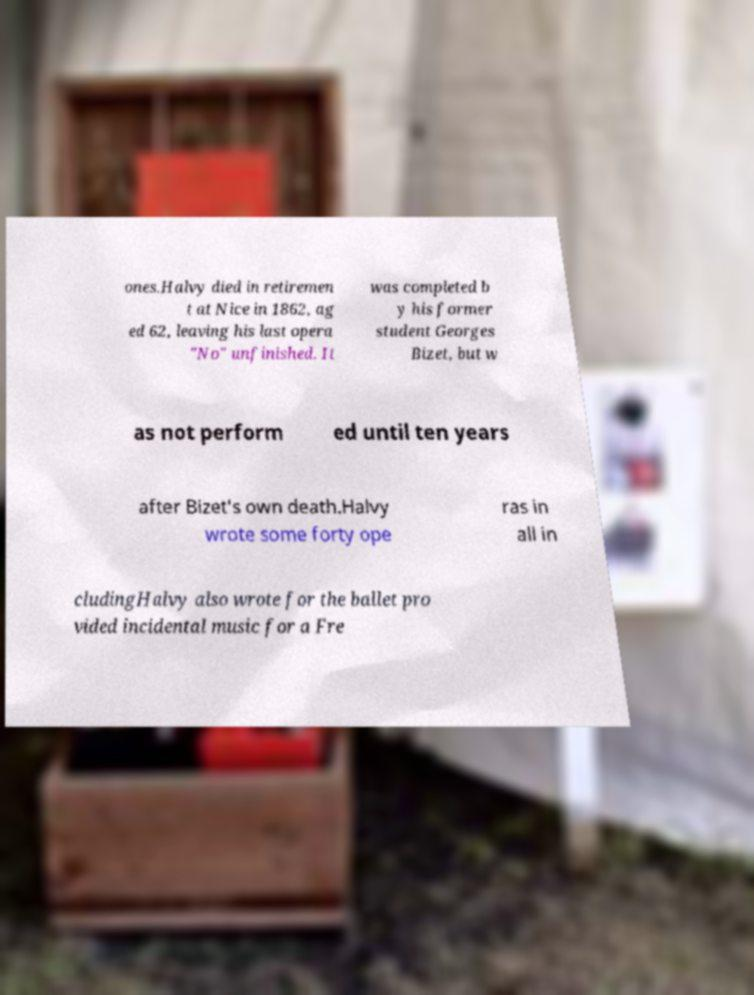Can you read and provide the text displayed in the image?This photo seems to have some interesting text. Can you extract and type it out for me? ones.Halvy died in retiremen t at Nice in 1862, ag ed 62, leaving his last opera "No" unfinished. It was completed b y his former student Georges Bizet, but w as not perform ed until ten years after Bizet's own death.Halvy wrote some forty ope ras in all in cludingHalvy also wrote for the ballet pro vided incidental music for a Fre 